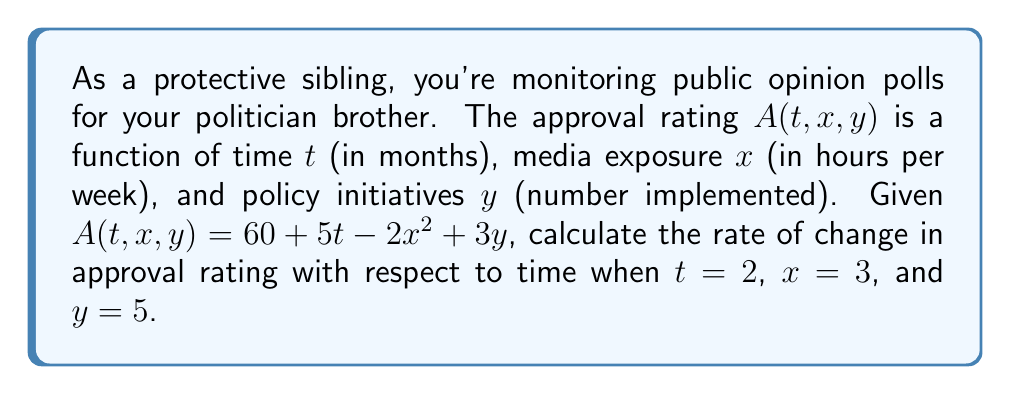Help me with this question. To find the rate of change in approval rating with respect to time, we need to calculate the partial derivative of $A$ with respect to $t$:

1) First, we find $\frac{\partial A}{\partial t}$:
   $$\frac{\partial A}{\partial t} = 5$$

2) This partial derivative is constant, meaning the rate of change with respect to time doesn't depend on the specific values of $t$, $x$, or $y$.

3) Therefore, at any point, including when $t=2$, $x=3$, and $y=5$, the rate of change in approval rating with respect to time is 5 percentage points per month.

4) We don't need to substitute the given values into the equation because the result is independent of these variables.
Answer: 5 percentage points per month 